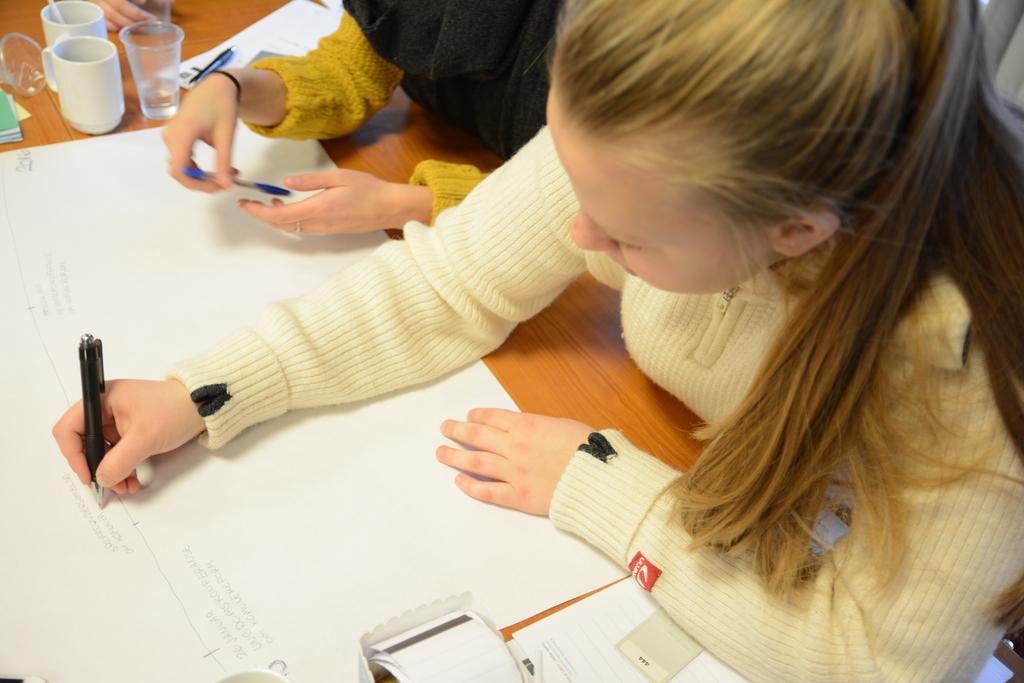Can you describe this image briefly? In the image there are two kids sitting in front of the table and writing something on a chart placed on the table, around that chart there are cups, glasses and some other items. 